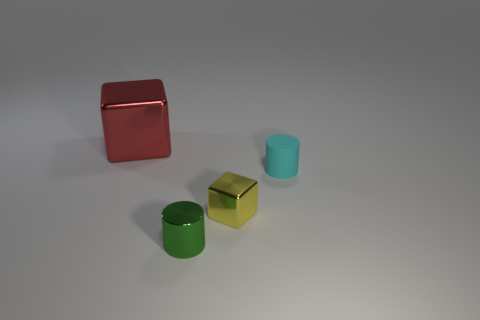How many shiny objects are left of the block in front of the red thing?
Provide a succinct answer. 2. There is a small object that is both on the right side of the tiny shiny cylinder and left of the small rubber cylinder; what material is it?
Your response must be concise. Metal. Is the shape of the shiny object that is behind the small metal block the same as  the yellow metal object?
Keep it short and to the point. Yes. Are there fewer tiny yellow things than tiny cyan metallic things?
Give a very brief answer. No. There is a small rubber thing; is it the same color as the shiny block behind the cyan rubber cylinder?
Ensure brevity in your answer.  No. Are there more blue matte spheres than metal cylinders?
Offer a terse response. No. There is a cyan thing that is the same shape as the small green shiny thing; what size is it?
Offer a very short reply. Small. Does the green cylinder have the same material as the cube on the right side of the green metal cylinder?
Provide a short and direct response. Yes. How many things are either tiny cylinders or large red things?
Offer a terse response. 3. There is a block in front of the big red thing; is it the same size as the object to the left of the tiny green shiny object?
Give a very brief answer. No. 